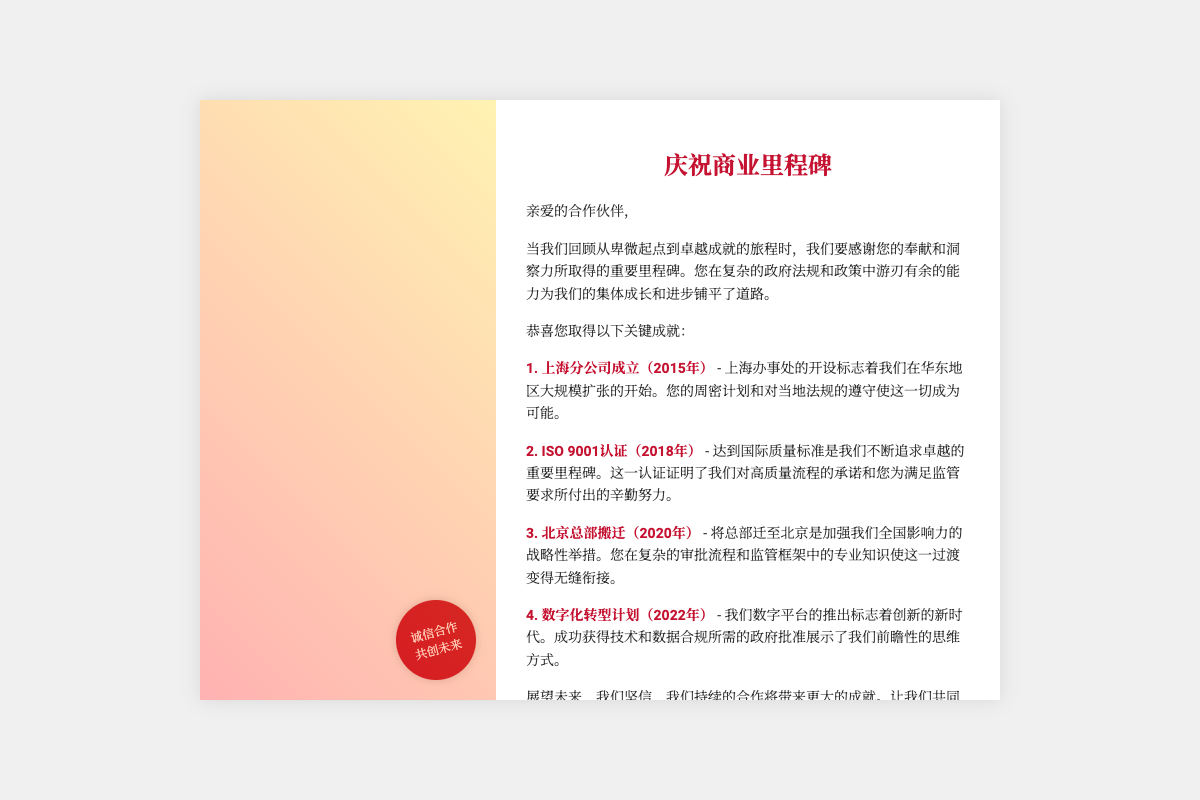what is the title of the card? The title of the card is "庆祝商业里程碑."
Answer: 庆祝商业里程碑 who is the intended recipient of the card? The card is addressed to "亲爱的合作伙伴," which translates to "Dear Partner."
Answer: 亲爱的合作伙伴 how many key achievements are listed? There are four key achievements mentioned in the card.
Answer: 4 what year was the Shanghai branch established? The Shanghai branch was established in the year 2015.
Answer: 2015 what certification was achieved in 2018? The certification achieved in 2018 was ISO 9001.
Answer: ISO 9001 which city is mentioned in relation to the headquarters relocation? The city mentioned in relation to the headquarters relocation is Beijing.
Answer: 北京 what was a significant aspect of the digital transformation plan? A significant aspect of the digital transformation plan was the launch of a digital platform.
Answer: 数字平台的推出 what does the seal on the cover say? The seal on the cover says "诚信合作\n共创未来."
Answer: 诚信合作共创未来 